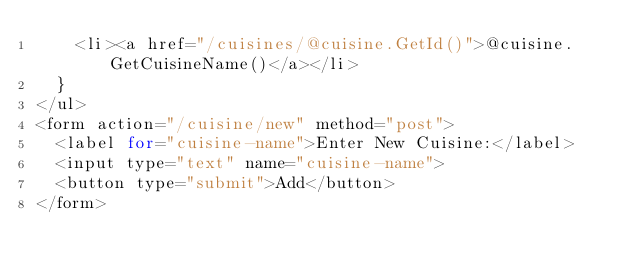Convert code to text. <code><loc_0><loc_0><loc_500><loc_500><_C#_>    <li><a href="/cuisines/@cuisine.GetId()">@cuisine.GetCuisineName()</a></li>
  }
</ul>
<form action="/cuisine/new" method="post">
  <label for="cuisine-name">Enter New Cuisine:</label>
  <input type="text" name="cuisine-name">
  <button type="submit">Add</button>
</form>
</code> 